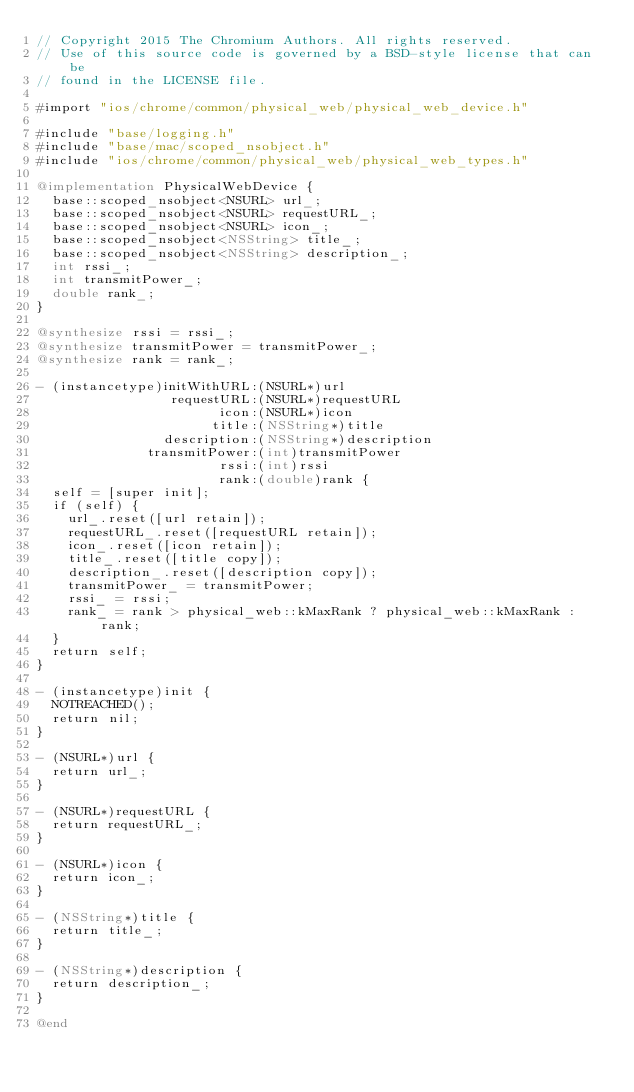Convert code to text. <code><loc_0><loc_0><loc_500><loc_500><_ObjectiveC_>// Copyright 2015 The Chromium Authors. All rights reserved.
// Use of this source code is governed by a BSD-style license that can be
// found in the LICENSE file.

#import "ios/chrome/common/physical_web/physical_web_device.h"

#include "base/logging.h"
#include "base/mac/scoped_nsobject.h"
#include "ios/chrome/common/physical_web/physical_web_types.h"

@implementation PhysicalWebDevice {
  base::scoped_nsobject<NSURL> url_;
  base::scoped_nsobject<NSURL> requestURL_;
  base::scoped_nsobject<NSURL> icon_;
  base::scoped_nsobject<NSString> title_;
  base::scoped_nsobject<NSString> description_;
  int rssi_;
  int transmitPower_;
  double rank_;
}

@synthesize rssi = rssi_;
@synthesize transmitPower = transmitPower_;
@synthesize rank = rank_;

- (instancetype)initWithURL:(NSURL*)url
                 requestURL:(NSURL*)requestURL
                       icon:(NSURL*)icon
                      title:(NSString*)title
                description:(NSString*)description
              transmitPower:(int)transmitPower
                       rssi:(int)rssi
                       rank:(double)rank {
  self = [super init];
  if (self) {
    url_.reset([url retain]);
    requestURL_.reset([requestURL retain]);
    icon_.reset([icon retain]);
    title_.reset([title copy]);
    description_.reset([description copy]);
    transmitPower_ = transmitPower;
    rssi_ = rssi;
    rank_ = rank > physical_web::kMaxRank ? physical_web::kMaxRank : rank;
  }
  return self;
}

- (instancetype)init {
  NOTREACHED();
  return nil;
}

- (NSURL*)url {
  return url_;
}

- (NSURL*)requestURL {
  return requestURL_;
}

- (NSURL*)icon {
  return icon_;
}

- (NSString*)title {
  return title_;
}

- (NSString*)description {
  return description_;
}

@end
</code> 